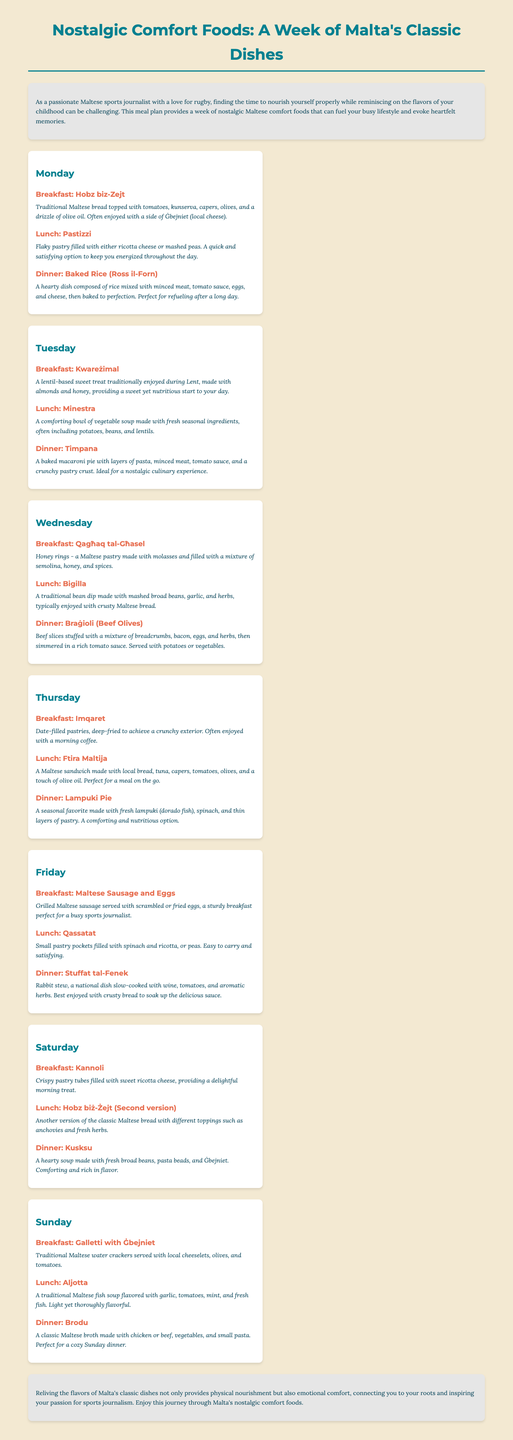what is the title of the document? The title of the document is provided at the top of the HTML structure.
Answer: Nostalgic Comfort Foods: A Week of Malta's Classic Dishes how many days are covered in the meal plan? The meal plan specifies meals for each day of the week from Monday to Sunday, totaling seven days.
Answer: 7 days what is the breakfast on Tuesday? The specific breakfast for Tuesday is listed under that day's meal section.
Answer: Kwareżimal which dish is a traditional Maltese bread served with toppings? The document mentions a specific dish known for its traditional bread and toppings.
Answer: Hobz biz-Zejt what type of stew is served for Friday dinner? The dinner meal on Friday is noted for its specific type of meat and preparation method.
Answer: Stuffat tal-Fenek what is the main ingredient in Timpana? The meal labeled Timpana details its main components, which include a specific type of pasta.
Answer: macaroni name a dessert mentioned in the meal plan. The document lists several desserts, drawing from traditional Maltese sweets.
Answer: Kannoli what type of soup is featured on Sunday lunch? The soup served during Sunday lunch is identified in the meal plan under that specific section.
Answer: Aljotta 